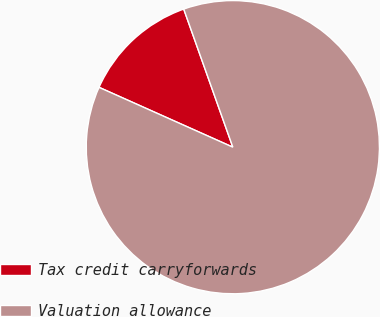Convert chart to OTSL. <chart><loc_0><loc_0><loc_500><loc_500><pie_chart><fcel>Tax credit carryforwards<fcel>Valuation allowance<nl><fcel>12.87%<fcel>87.13%<nl></chart> 